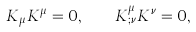Convert formula to latex. <formula><loc_0><loc_0><loc_500><loc_500>K _ { \mu } K ^ { \mu } = 0 , \quad K ^ { \mu } _ { ; \nu } K ^ { \nu } = 0 ,</formula> 